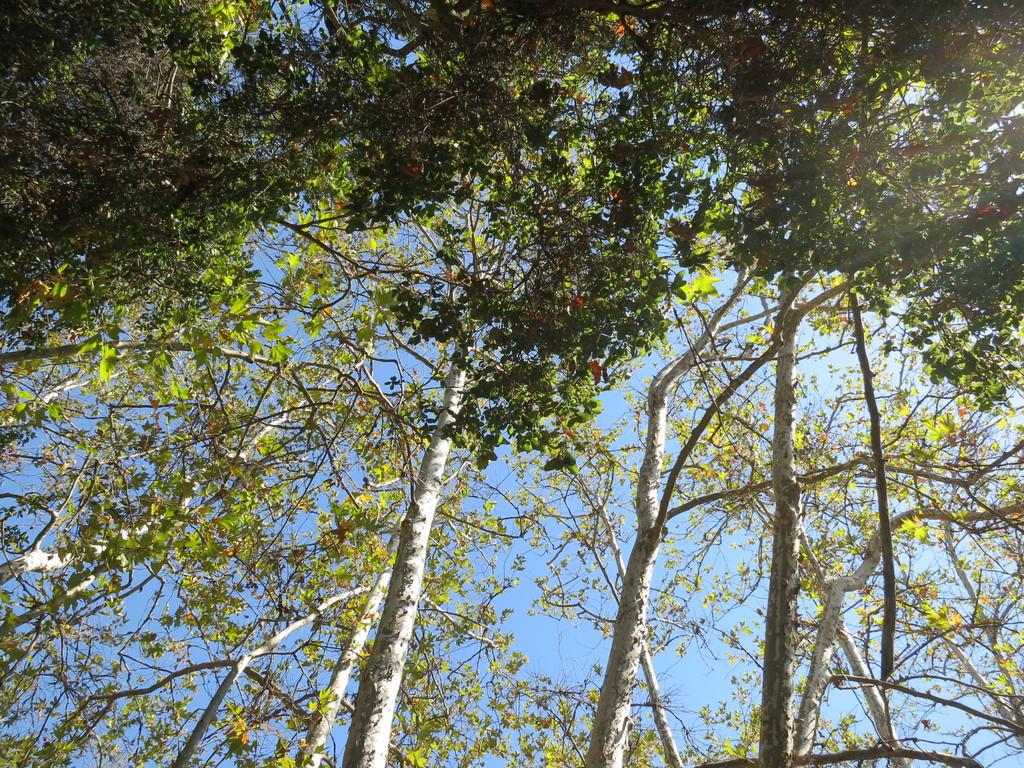What type of vegetation is present in the image? There are green color trees in the image. What color is the sky in the image? The sky is blue in the image. In which direction are the trees leaning in the image? The trees are not leaning in any specific direction in the image. What type of tub is visible in the image? There is no tub present in the image. What type of teeth can be seen in the image? There are no teeth visible in the image. 